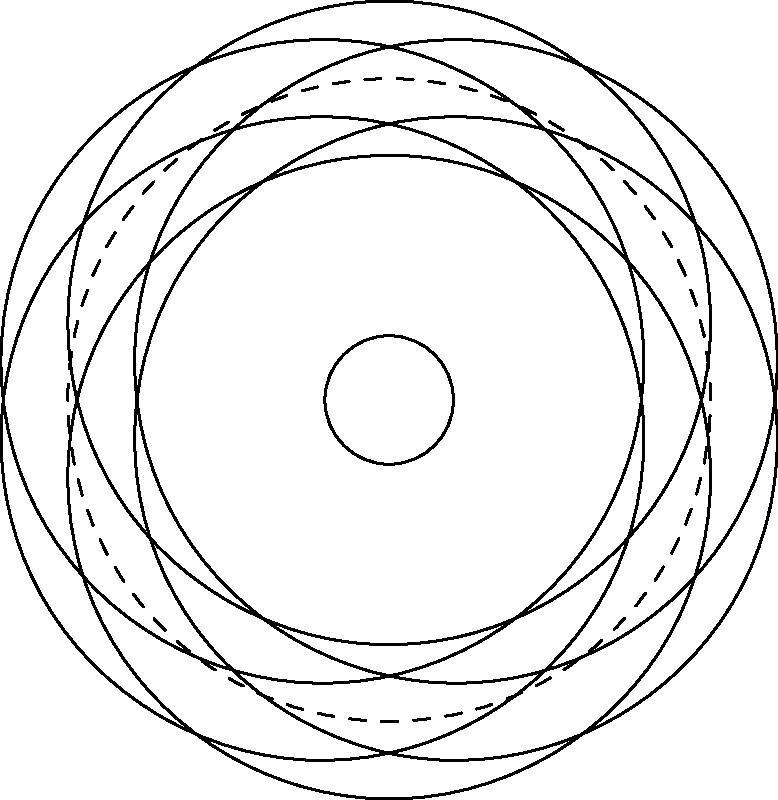Analyze the symmetry present in the sacred geometry pattern shown above. How does this symmetry relate to the concept of unity in spiritual philosophies, and what implications does it have for our understanding of the universe's fundamental structure? 1. Observe the pattern: The image depicts a "Flower of Life" pattern, a fundamental sacred geometry symbol.

2. Identify symmetry: The pattern exhibits 6-fold rotational symmetry and multiple axes of reflection symmetry.

3. Rotational symmetry: The pattern remains unchanged when rotated by multiples of 60 degrees (360°/6), indicating perfect balance and cyclical nature.

4. Reflection symmetry: There are 6 axes of reflection, each bisecting the petals, symbolizing duality and balance.

5. Unity in diversity: The pattern is composed of multiple overlapping circles, yet forms a cohesive whole, representing interconnectedness.

6. Spiritual significance: In many spiritual traditions, this pattern represents the fundamental patterns of creation and the interconnectedness of all life.

7. Universal structure: The symmetry suggests an underlying order in the universe, reflecting the philosophical concept of a harmonious cosmos.

8. Fractal nature: The pattern can be infinitely expanded, mirroring the idea of self-similarity across different scales in the universe.

9. Implications for understanding: This symmetry implies that fundamental principles of order and balance may exist at all levels of reality, from the microscopic to the cosmic.

10. Philosophical reflection: The pattern's perfect symmetry raises questions about the nature of reality - whether the universe is inherently ordered or if we impose order through our perception.
Answer: The symmetry in the Flower of Life pattern represents cosmic unity, interconnectedness, and fundamental order in the universe, challenging us to consider the inherent structure of reality and our perception of it. 